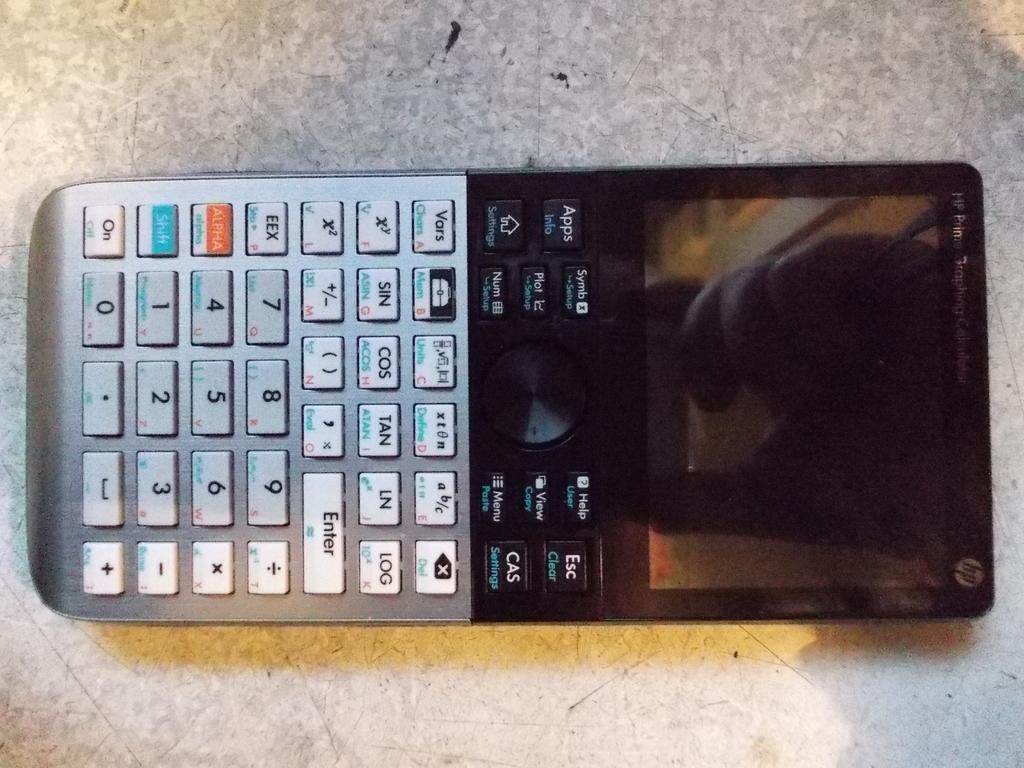Provide a one-sentence caption for the provided image. A electronic device with a screen and numbers and other tabs from HP. 